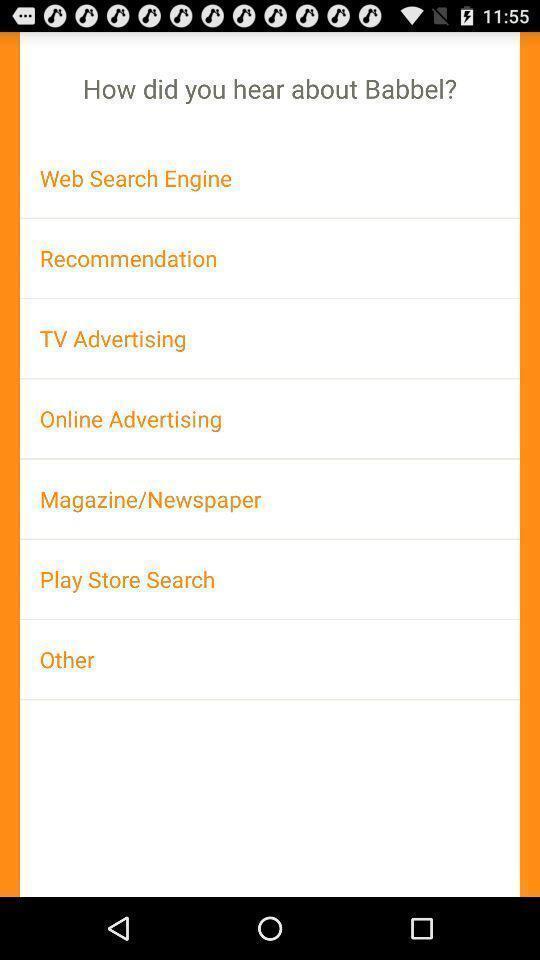Summarize the main components in this picture. Page displaying various option regarding info. 